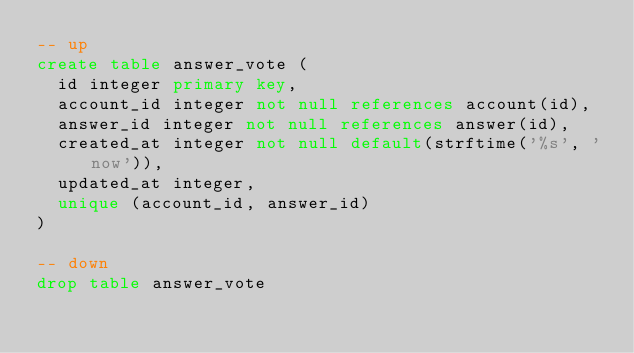Convert code to text. <code><loc_0><loc_0><loc_500><loc_500><_SQL_>-- up
create table answer_vote (
  id integer primary key,
  account_id integer not null references account(id),
  answer_id integer not null references answer(id),
  created_at integer not null default(strftime('%s', 'now')),
  updated_at integer,
  unique (account_id, answer_id)
)

-- down
drop table answer_vote
</code> 